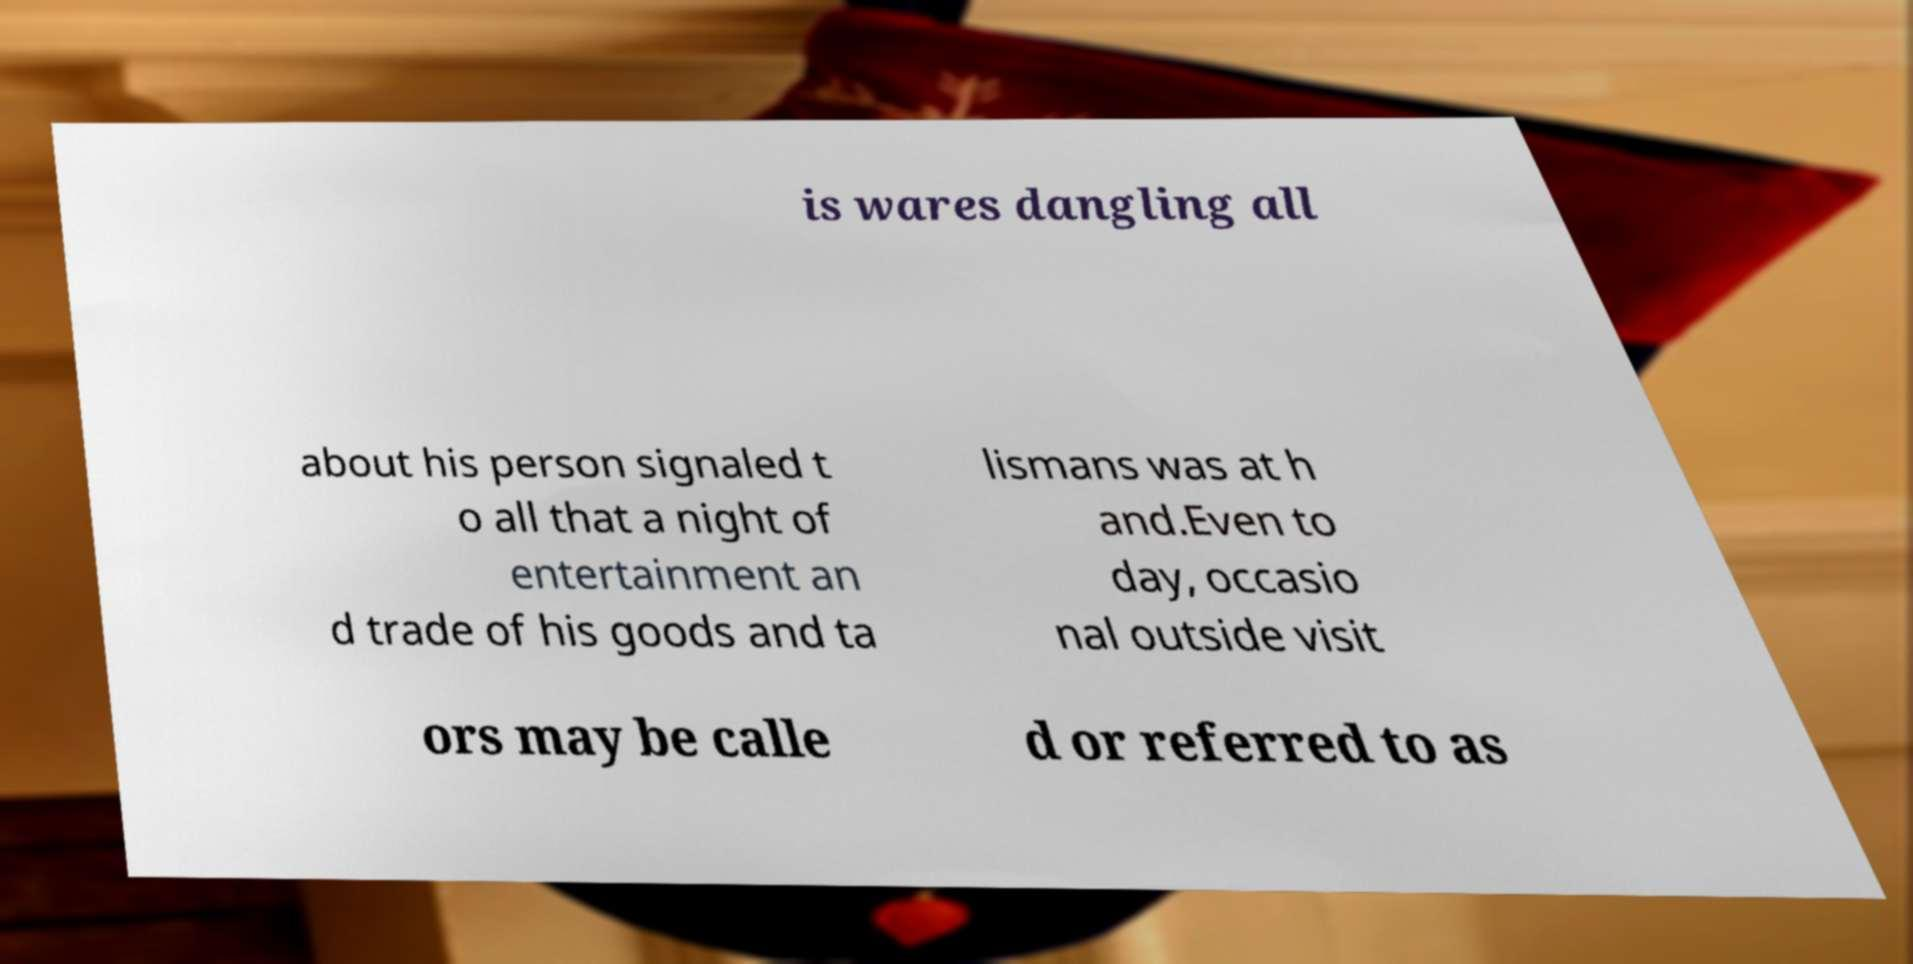I need the written content from this picture converted into text. Can you do that? is wares dangling all about his person signaled t o all that a night of entertainment an d trade of his goods and ta lismans was at h and.Even to day, occasio nal outside visit ors may be calle d or referred to as 